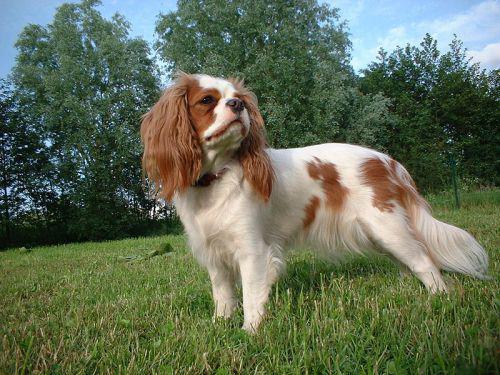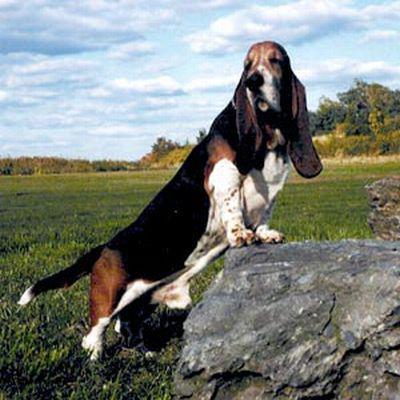The first image is the image on the left, the second image is the image on the right. Given the left and right images, does the statement "There are 2 dogs outdoors on the grass." hold true? Answer yes or no. Yes. The first image is the image on the left, the second image is the image on the right. Evaluate the accuracy of this statement regarding the images: "One of the images shows a basset hound with its body pointed toward the right.". Is it true? Answer yes or no. Yes. 